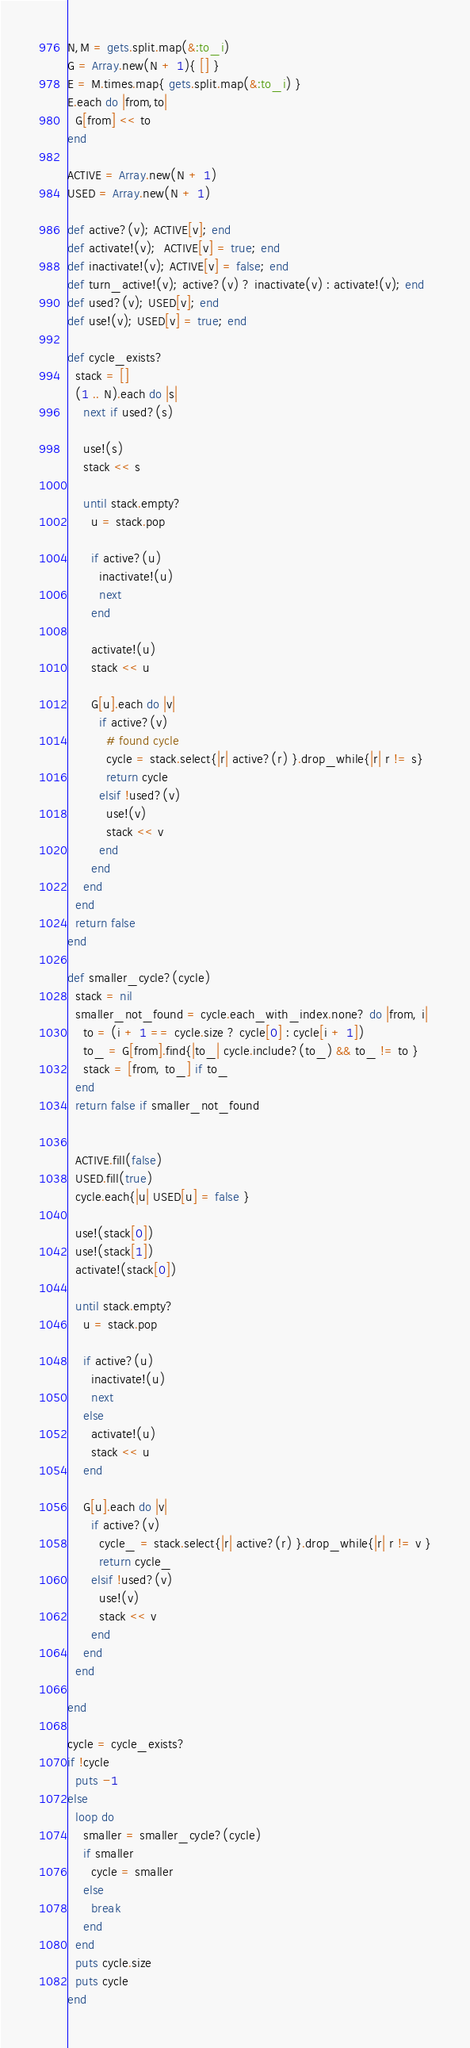<code> <loc_0><loc_0><loc_500><loc_500><_Ruby_>N,M = gets.split.map(&:to_i)
G = Array.new(N + 1){ [] }
E = M.times.map{ gets.split.map(&:to_i) }
E.each do |from,to|
  G[from] << to
end

ACTIVE = Array.new(N + 1)
USED = Array.new(N + 1)

def active?(v); ACTIVE[v]; end
def activate!(v);  ACTIVE[v] = true; end
def inactivate!(v); ACTIVE[v] = false; end
def turn_active!(v); active?(v) ? inactivate(v) : activate!(v); end
def used?(v); USED[v]; end
def use!(v); USED[v] = true; end

def cycle_exists?
  stack = []
  (1 .. N).each do |s|
    next if used?(s)
    
    use!(s)
    stack << s
    
    until stack.empty?
      u = stack.pop
      
      if active?(u)
        inactivate!(u)
        next
      end
      
      activate!(u)
      stack << u
      
      G[u].each do |v|
        if active?(v)
          # found cycle
          cycle = stack.select{|r| active?(r) }.drop_while{|r| r != s}
          return cycle
        elsif !used?(v)
          use!(v)
          stack << v
        end
      end
    end
  end
  return false
end

def smaller_cycle?(cycle)
  stack = nil
  smaller_not_found = cycle.each_with_index.none? do |from, i|
    to = (i + 1 == cycle.size ? cycle[0] : cycle[i + 1])
    to_ = G[from].find{|to_| cycle.include?(to_) && to_ != to }
    stack = [from, to_] if to_
  end
  return false if smaller_not_found
  
  
  ACTIVE.fill(false)
  USED.fill(true)
  cycle.each{|u| USED[u] = false }
  
  use!(stack[0])
  use!(stack[1])
  activate!(stack[0])

  until stack.empty?
    u = stack.pop
    
    if active?(u)
      inactivate!(u)
      next
    else
      activate!(u)
      stack << u
    end
    
    G[u].each do |v|
      if active?(v)
        cycle_ = stack.select{|r| active?(r) }.drop_while{|r| r != v }
        return cycle_
      elsif !used?(v)
        use!(v)
        stack << v
      end
    end
  end
  
end

cycle = cycle_exists?
if !cycle
  puts -1
else
  loop do
    smaller = smaller_cycle?(cycle)
    if smaller  
      cycle = smaller
    else
      break
    end
  end
  puts cycle.size
  puts cycle
end
</code> 